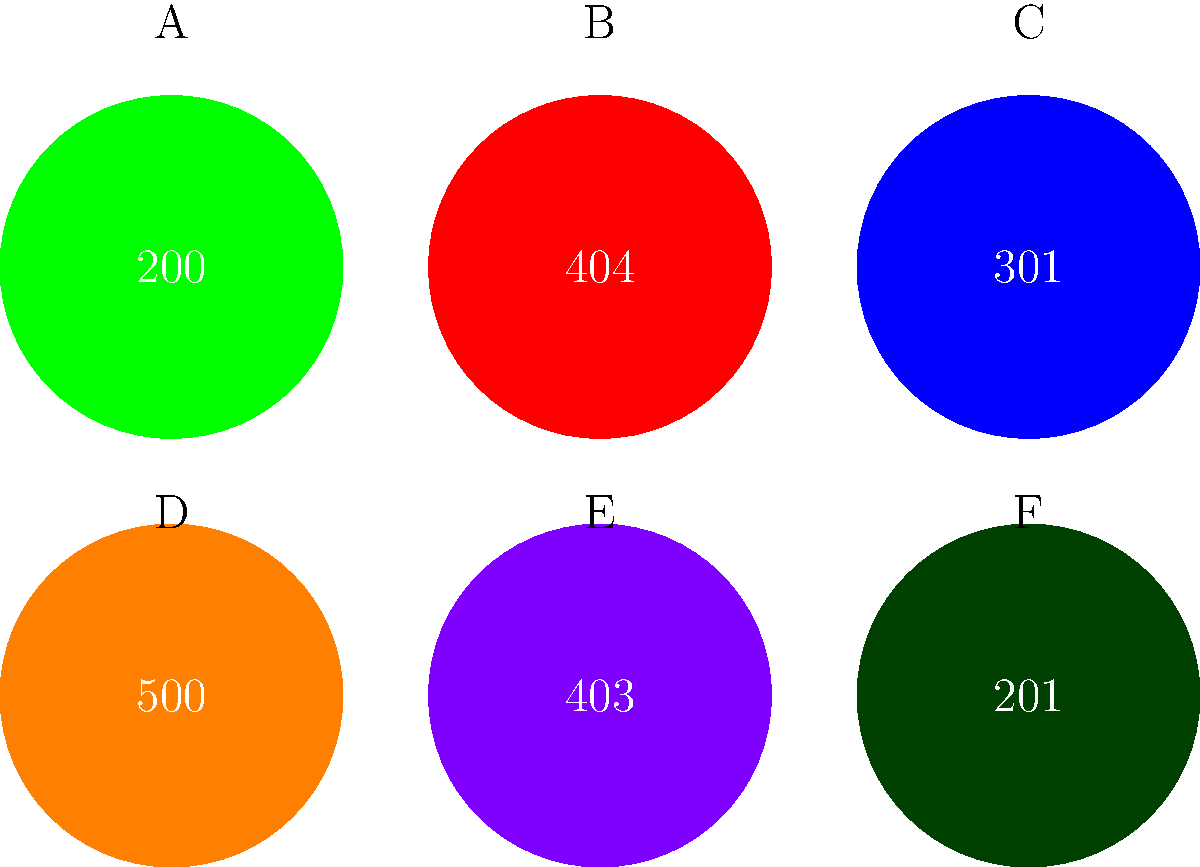As a software engineer familiar with web browsers, identify the HTTP status code represented by the icon labeled 'E' in the image above. To identify the HTTP status code represented by icon 'E', let's analyze the image step-by-step:

1. The image shows six circular icons, each containing an HTTP status code.
2. The icons are labeled A through F for easy reference.
3. Icon 'E' is located in the bottom row, second from the left.
4. The status code inside icon 'E' is 403.

HTTP status code 403 represents a "Forbidden" response. This means:

1. The server understood the request but refuses to authorize it.
2. The client does not have the necessary permissions to access the requested resource.
3. Unlike a 401 (Unauthorized) response, authenticating will not change the server's response.

As a software engineer working with web browsers, it's important to recognize this status code as it indicates a permission issue rather than an authentication problem or a missing resource.
Answer: 403 